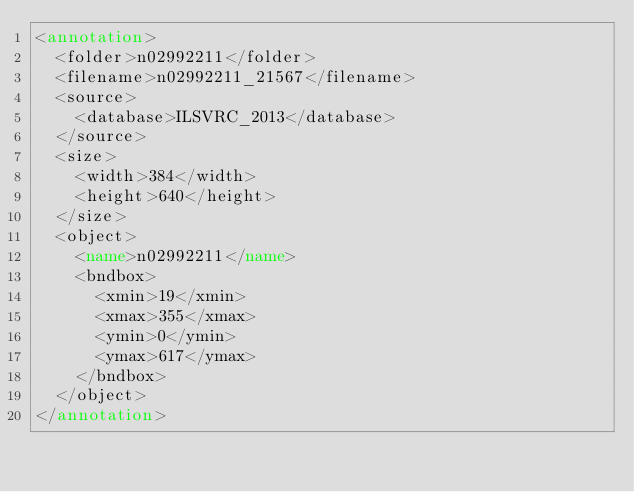Convert code to text. <code><loc_0><loc_0><loc_500><loc_500><_XML_><annotation>
	<folder>n02992211</folder>
	<filename>n02992211_21567</filename>
	<source>
		<database>ILSVRC_2013</database>
	</source>
	<size>
		<width>384</width>
		<height>640</height>
	</size>
	<object>
		<name>n02992211</name>
		<bndbox>
			<xmin>19</xmin>
			<xmax>355</xmax>
			<ymin>0</ymin>
			<ymax>617</ymax>
		</bndbox>
	</object>
</annotation>
</code> 